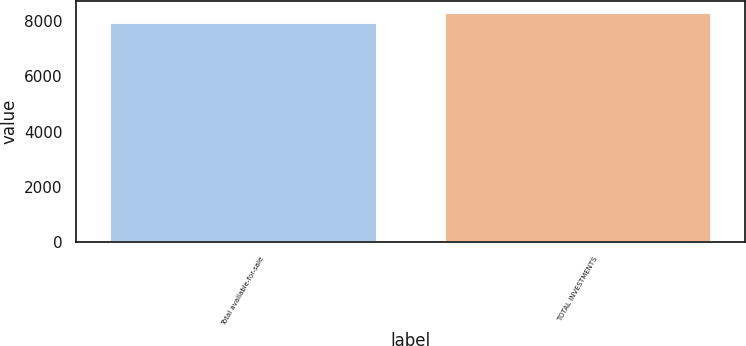Convert chart. <chart><loc_0><loc_0><loc_500><loc_500><bar_chart><fcel>Total available-for-sale<fcel>TOTAL INVESTMENTS<nl><fcel>7964<fcel>8317<nl></chart> 